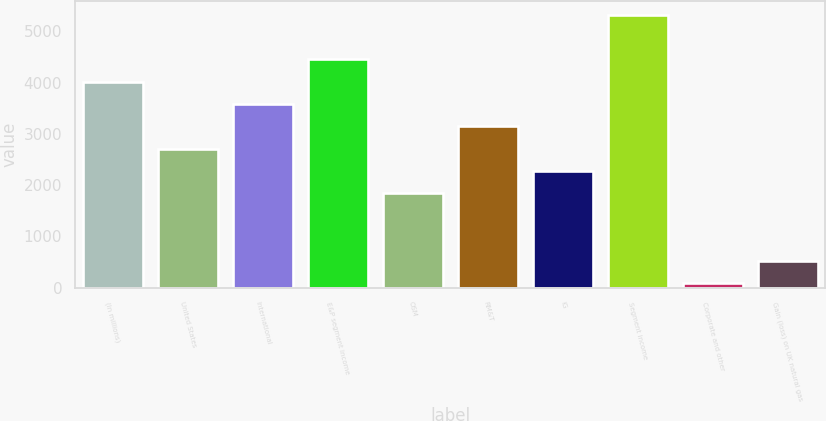Convert chart. <chart><loc_0><loc_0><loc_500><loc_500><bar_chart><fcel>(In millions)<fcel>United States<fcel>International<fcel>E&P segment income<fcel>OSM<fcel>RM&T<fcel>IG<fcel>Segment income<fcel>Corporate and other<fcel>Gain (loss) on UK natural gas<nl><fcel>4017.9<fcel>2709.6<fcel>3581.8<fcel>4454<fcel>1837.4<fcel>3145.7<fcel>2273.5<fcel>5326.2<fcel>93<fcel>529.1<nl></chart> 